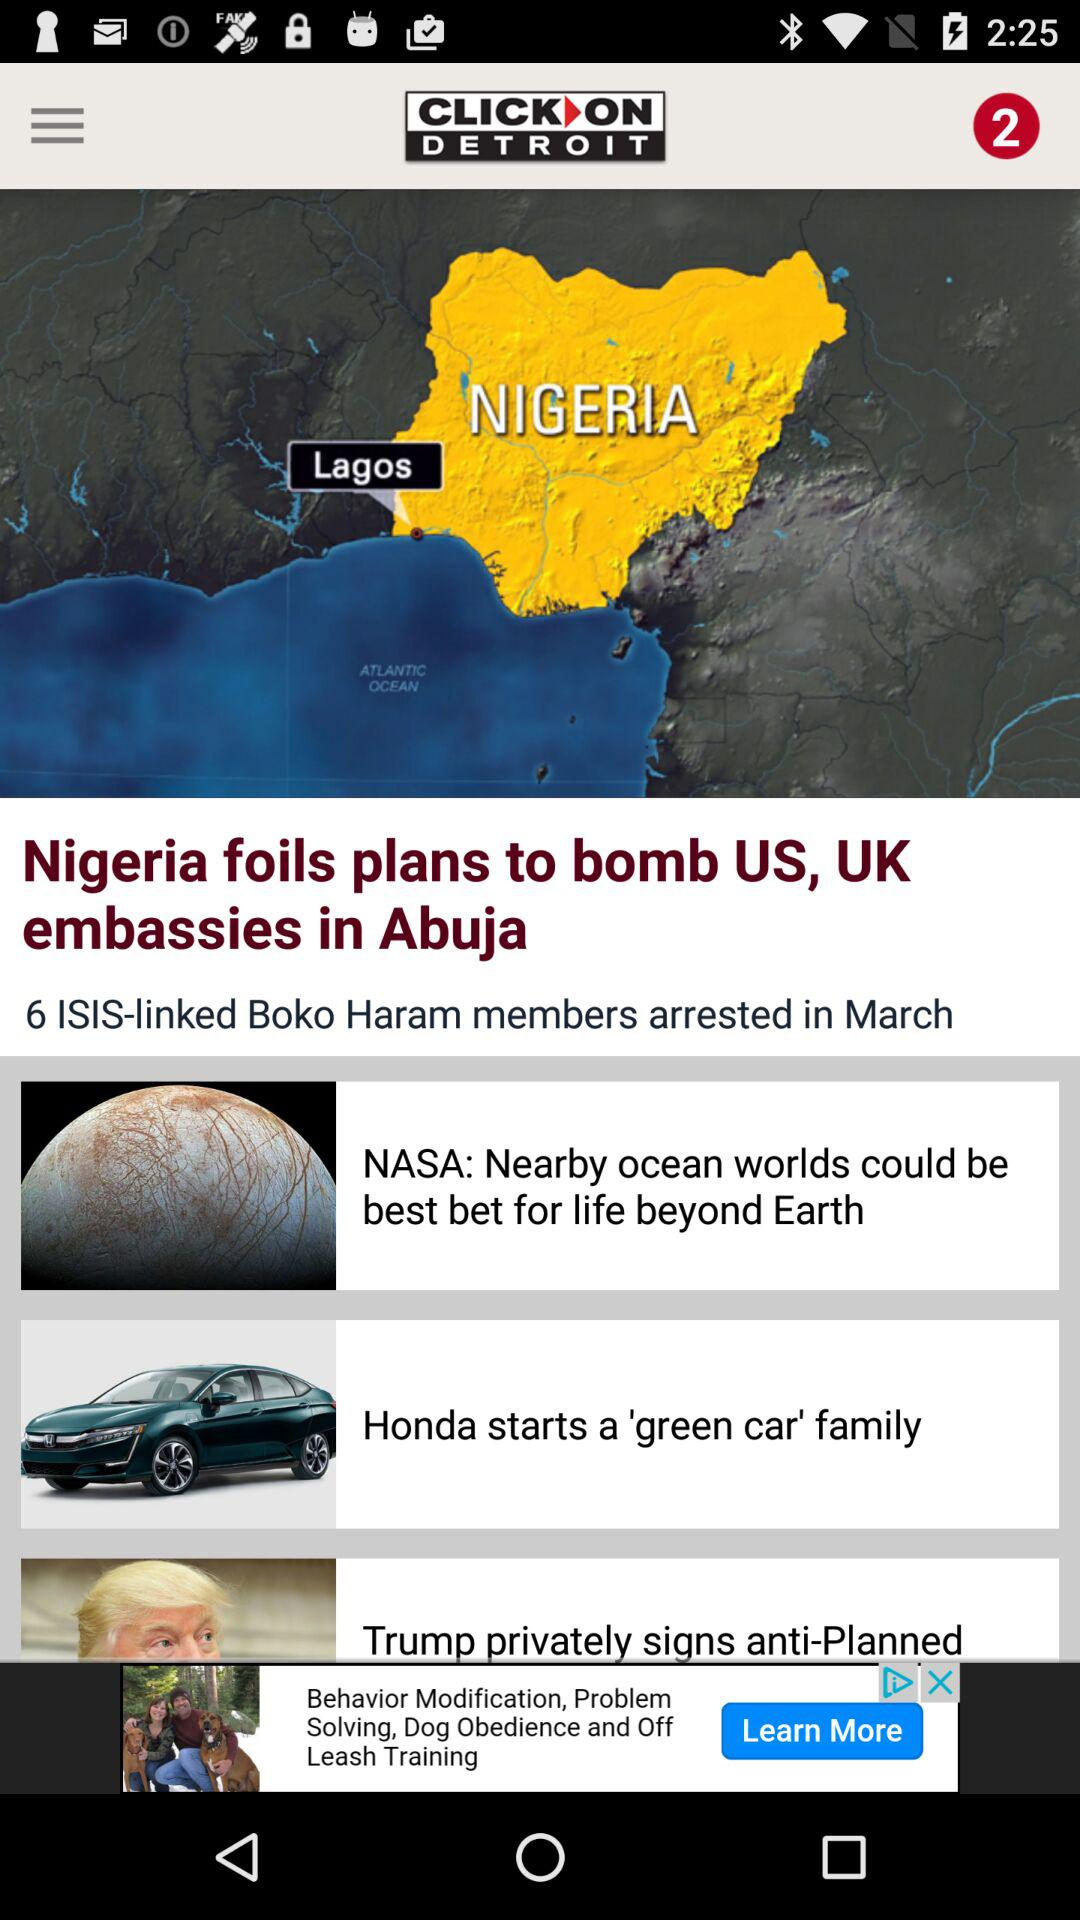How many members of "Boko Haram" were arrested? There were 6 members of "Boko Haram" who were arrested. 